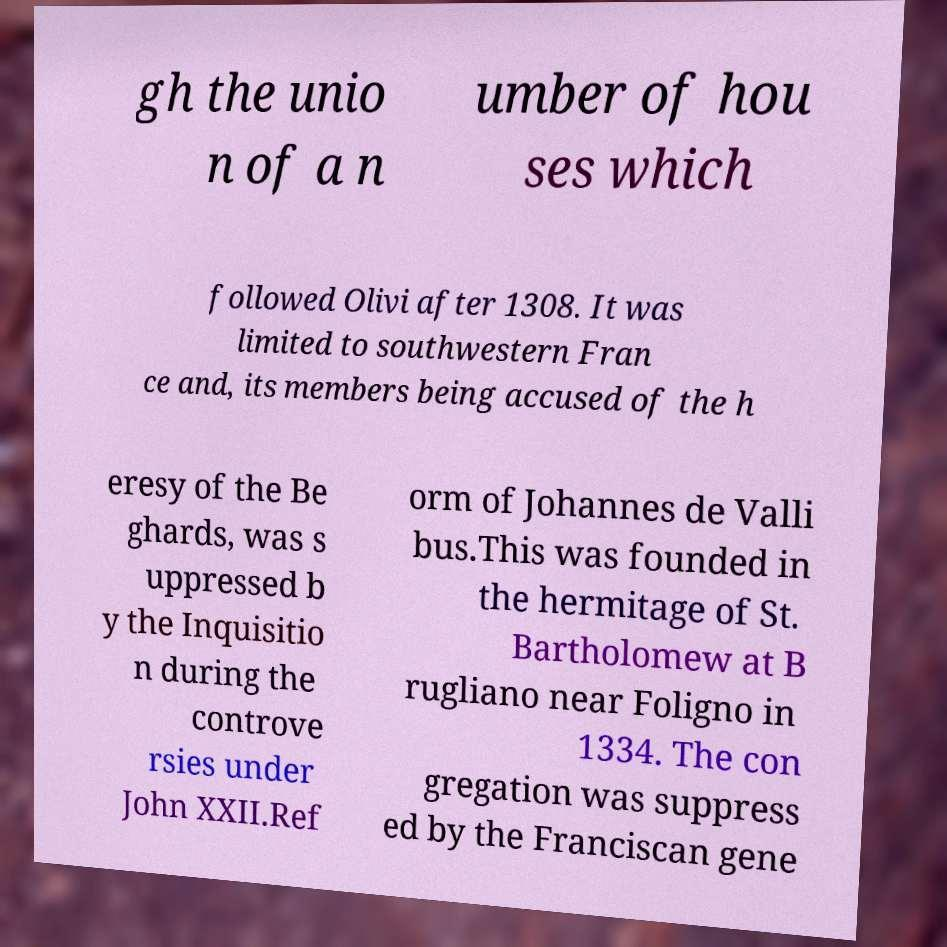Could you assist in decoding the text presented in this image and type it out clearly? gh the unio n of a n umber of hou ses which followed Olivi after 1308. It was limited to southwestern Fran ce and, its members being accused of the h eresy of the Be ghards, was s uppressed b y the Inquisitio n during the controve rsies under John XXII.Ref orm of Johannes de Valli bus.This was founded in the hermitage of St. Bartholomew at B rugliano near Foligno in 1334. The con gregation was suppress ed by the Franciscan gene 